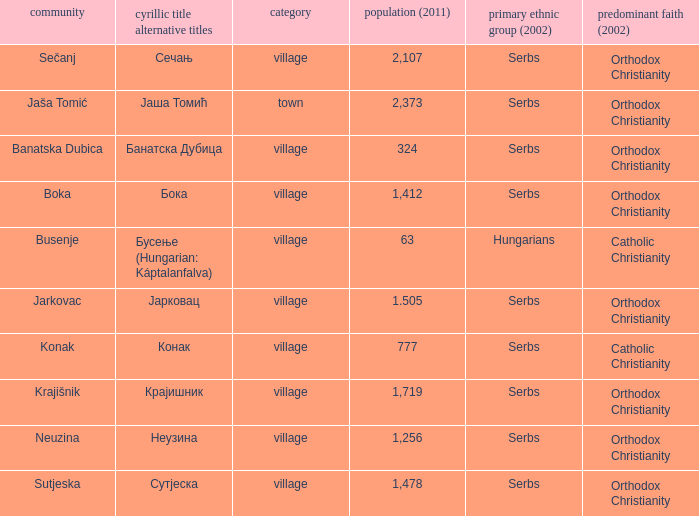The pooulation of јарковац is? 1.505. 